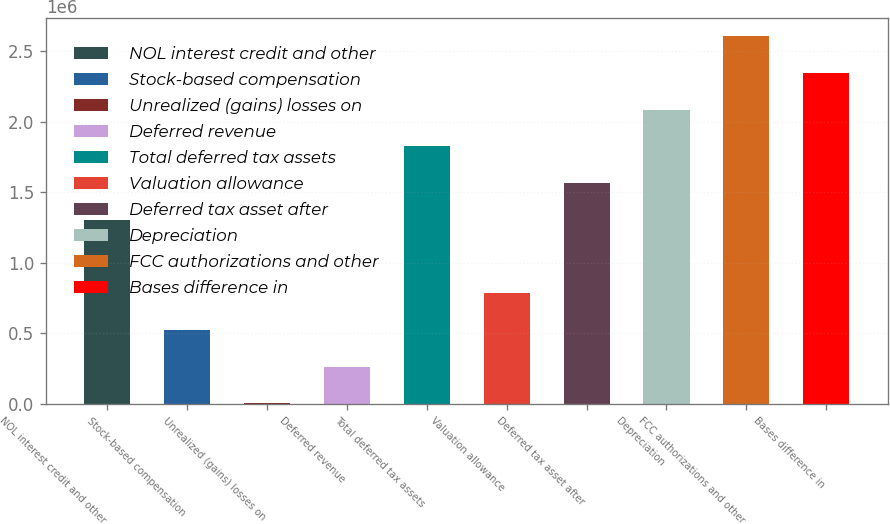Convert chart. <chart><loc_0><loc_0><loc_500><loc_500><bar_chart><fcel>NOL interest credit and other<fcel>Stock-based compensation<fcel>Unrealized (gains) losses on<fcel>Deferred revenue<fcel>Total deferred tax assets<fcel>Valuation allowance<fcel>Deferred tax asset after<fcel>Depreciation<fcel>FCC authorizations and other<fcel>Bases difference in<nl><fcel>1.3062e+06<fcel>525433<fcel>4918<fcel>265175<fcel>1.82672e+06<fcel>785690<fcel>1.56646e+06<fcel>2.08698e+06<fcel>2.60749e+06<fcel>2.34723e+06<nl></chart> 